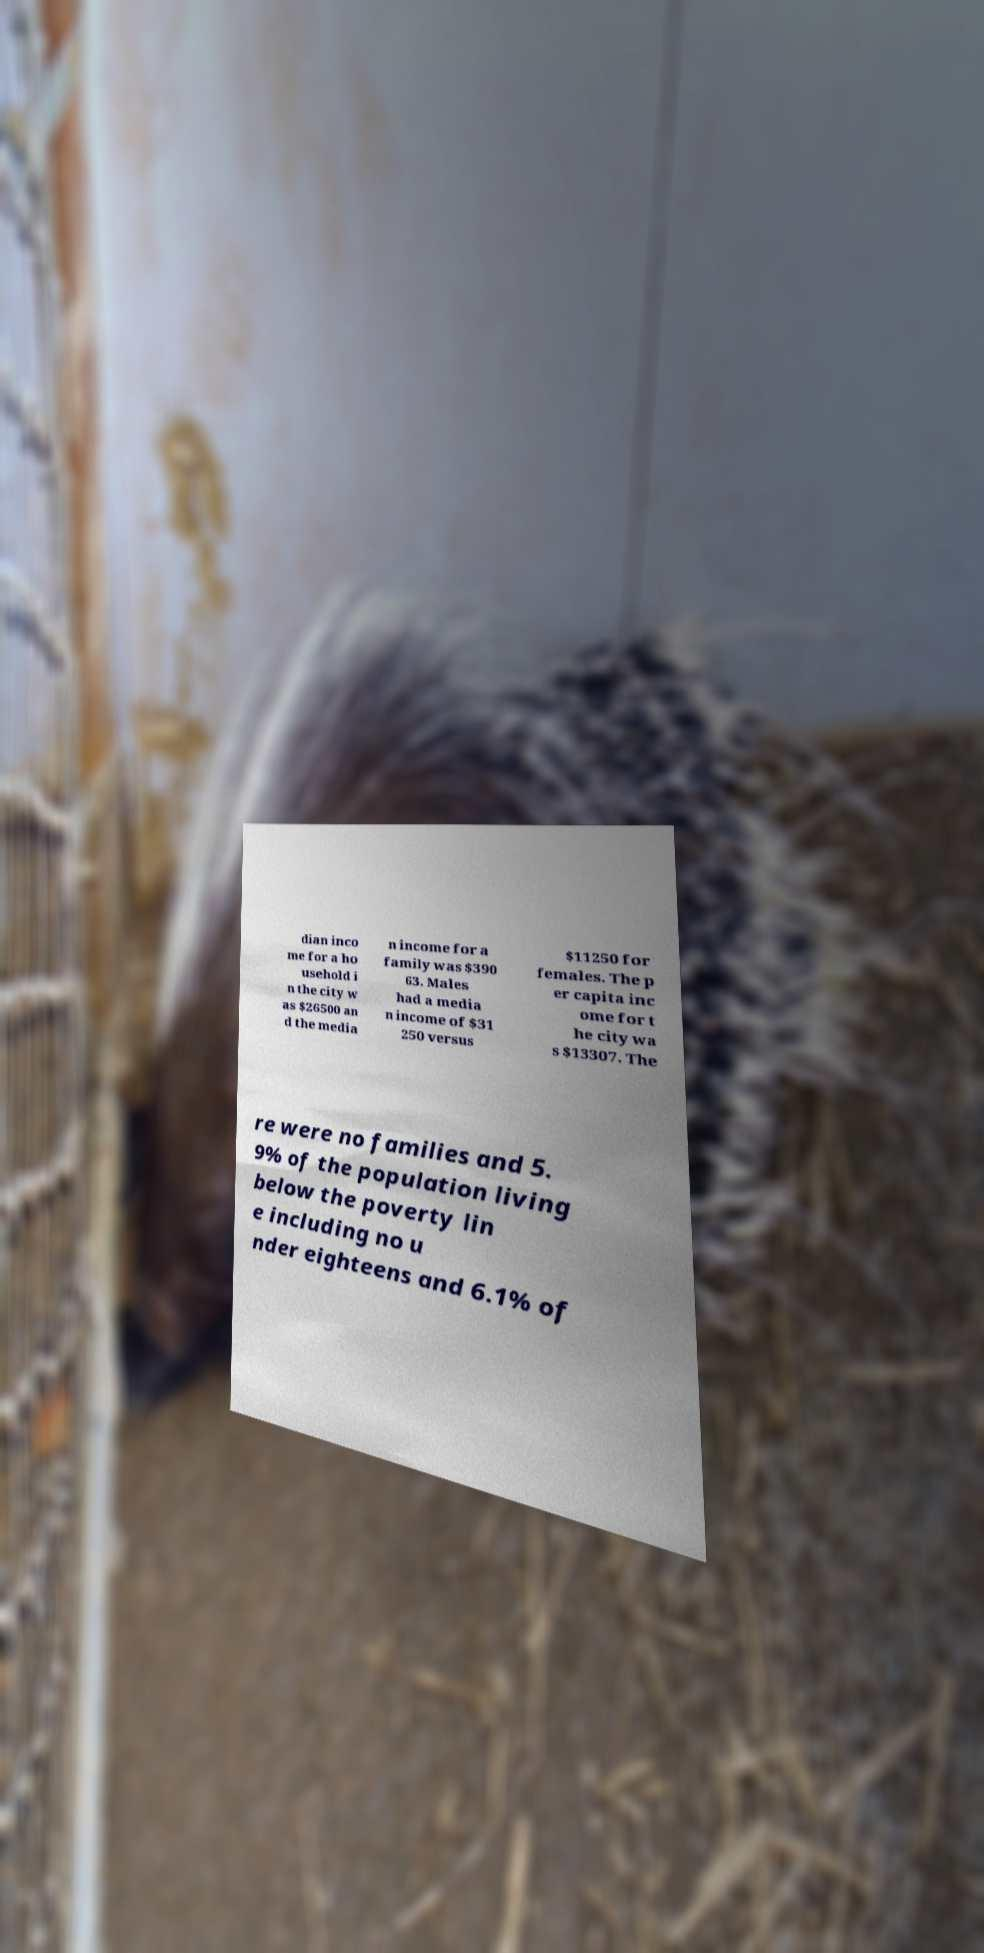There's text embedded in this image that I need extracted. Can you transcribe it verbatim? dian inco me for a ho usehold i n the city w as $26500 an d the media n income for a family was $390 63. Males had a media n income of $31 250 versus $11250 for females. The p er capita inc ome for t he city wa s $13307. The re were no families and 5. 9% of the population living below the poverty lin e including no u nder eighteens and 6.1% of 